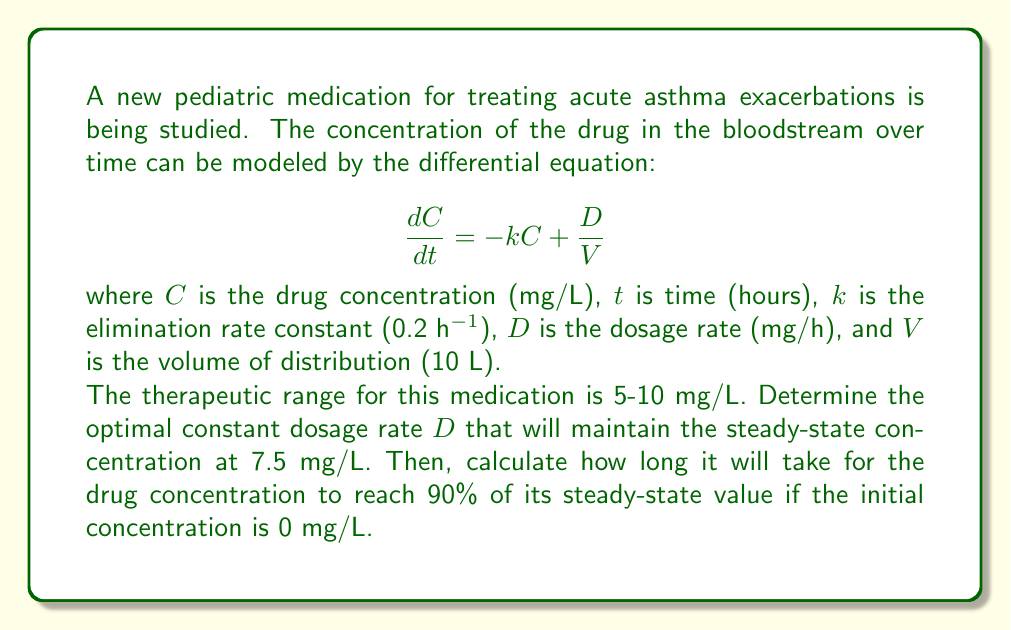Could you help me with this problem? To solve this problem, we'll follow these steps:

1. Find the steady-state concentration:
At steady-state, $\frac{dC}{dt} = 0$, so:

$$0 = -kC_{ss} + \frac{D}{V}$$

Where $C_{ss}$ is the steady-state concentration.

2. Solve for the dosage rate $D$:
Rearranging the equation:

$$D = kC_{ss}V$$

Substituting the given values:

$$D = 0.2 \text{ h}^{-1} \cdot 7.5 \text{ mg/L} \cdot 10 \text{ L} = 15 \text{ mg/h}$$

3. Calculate the time to reach 90% of steady-state:
The general solution for this first-order differential equation is:

$$C(t) = C_{ss}(1 - e^{-kt}) + C_0e^{-kt}$$

Where $C_0$ is the initial concentration (0 mg/L in this case).

We want to find $t$ when $C(t) = 0.9C_{ss}$:

$$0.9C_{ss} = C_{ss}(1 - e^{-kt}) + 0$$

Simplifying:

$$0.9 = 1 - e^{-kt}$$
$$0.1 = e^{-kt}$$
$$\ln(0.1) = -kt$$
$$t = \frac{-\ln(0.1)}{k} = \frac{2.30259}{0.2} = 11.51295 \text{ hours}$$
Answer: The optimal constant dosage rate is 15 mg/h, and it will take approximately 11.51 hours for the drug concentration to reach 90% of its steady-state value. 